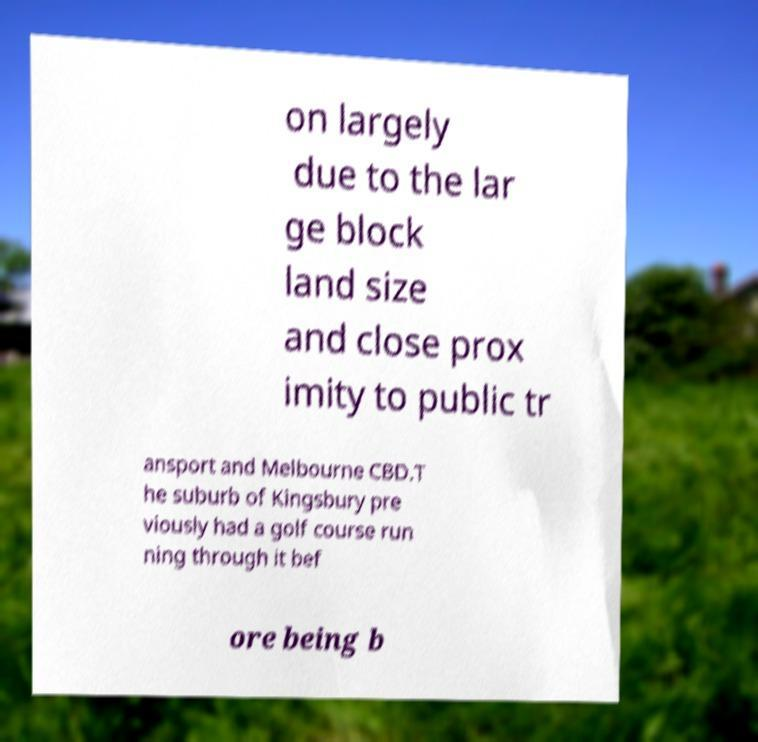Please read and relay the text visible in this image. What does it say? on largely due to the lar ge block land size and close prox imity to public tr ansport and Melbourne CBD.T he suburb of Kingsbury pre viously had a golf course run ning through it bef ore being b 